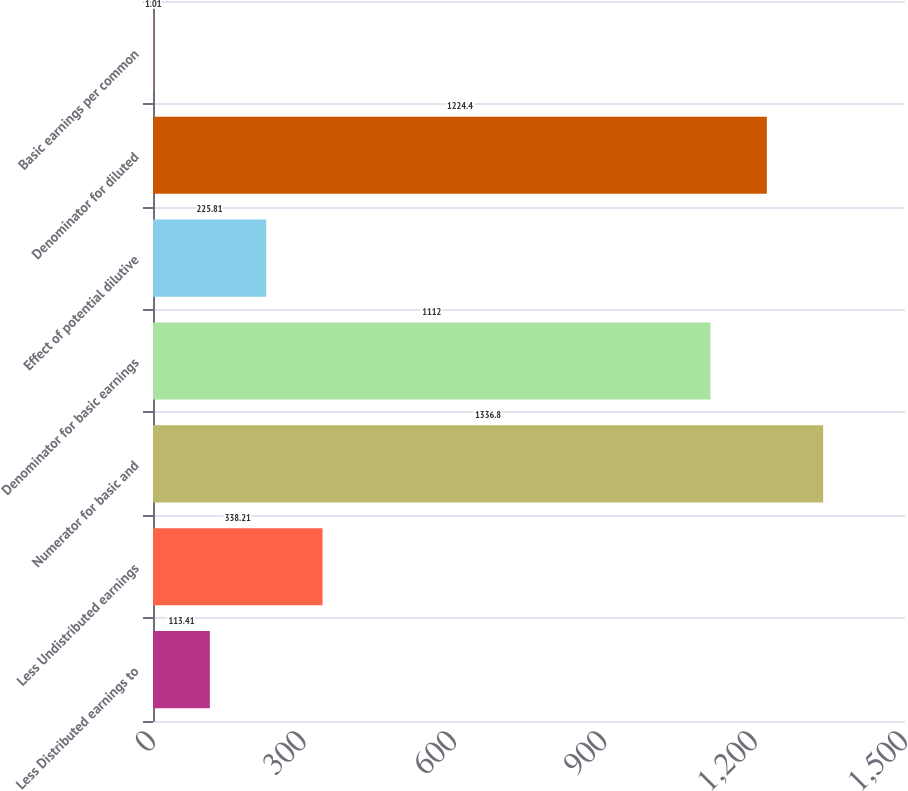Convert chart to OTSL. <chart><loc_0><loc_0><loc_500><loc_500><bar_chart><fcel>Less Distributed earnings to<fcel>Less Undistributed earnings<fcel>Numerator for basic and<fcel>Denominator for basic earnings<fcel>Effect of potential dilutive<fcel>Denominator for diluted<fcel>Basic earnings per common<nl><fcel>113.41<fcel>338.21<fcel>1336.8<fcel>1112<fcel>225.81<fcel>1224.4<fcel>1.01<nl></chart> 